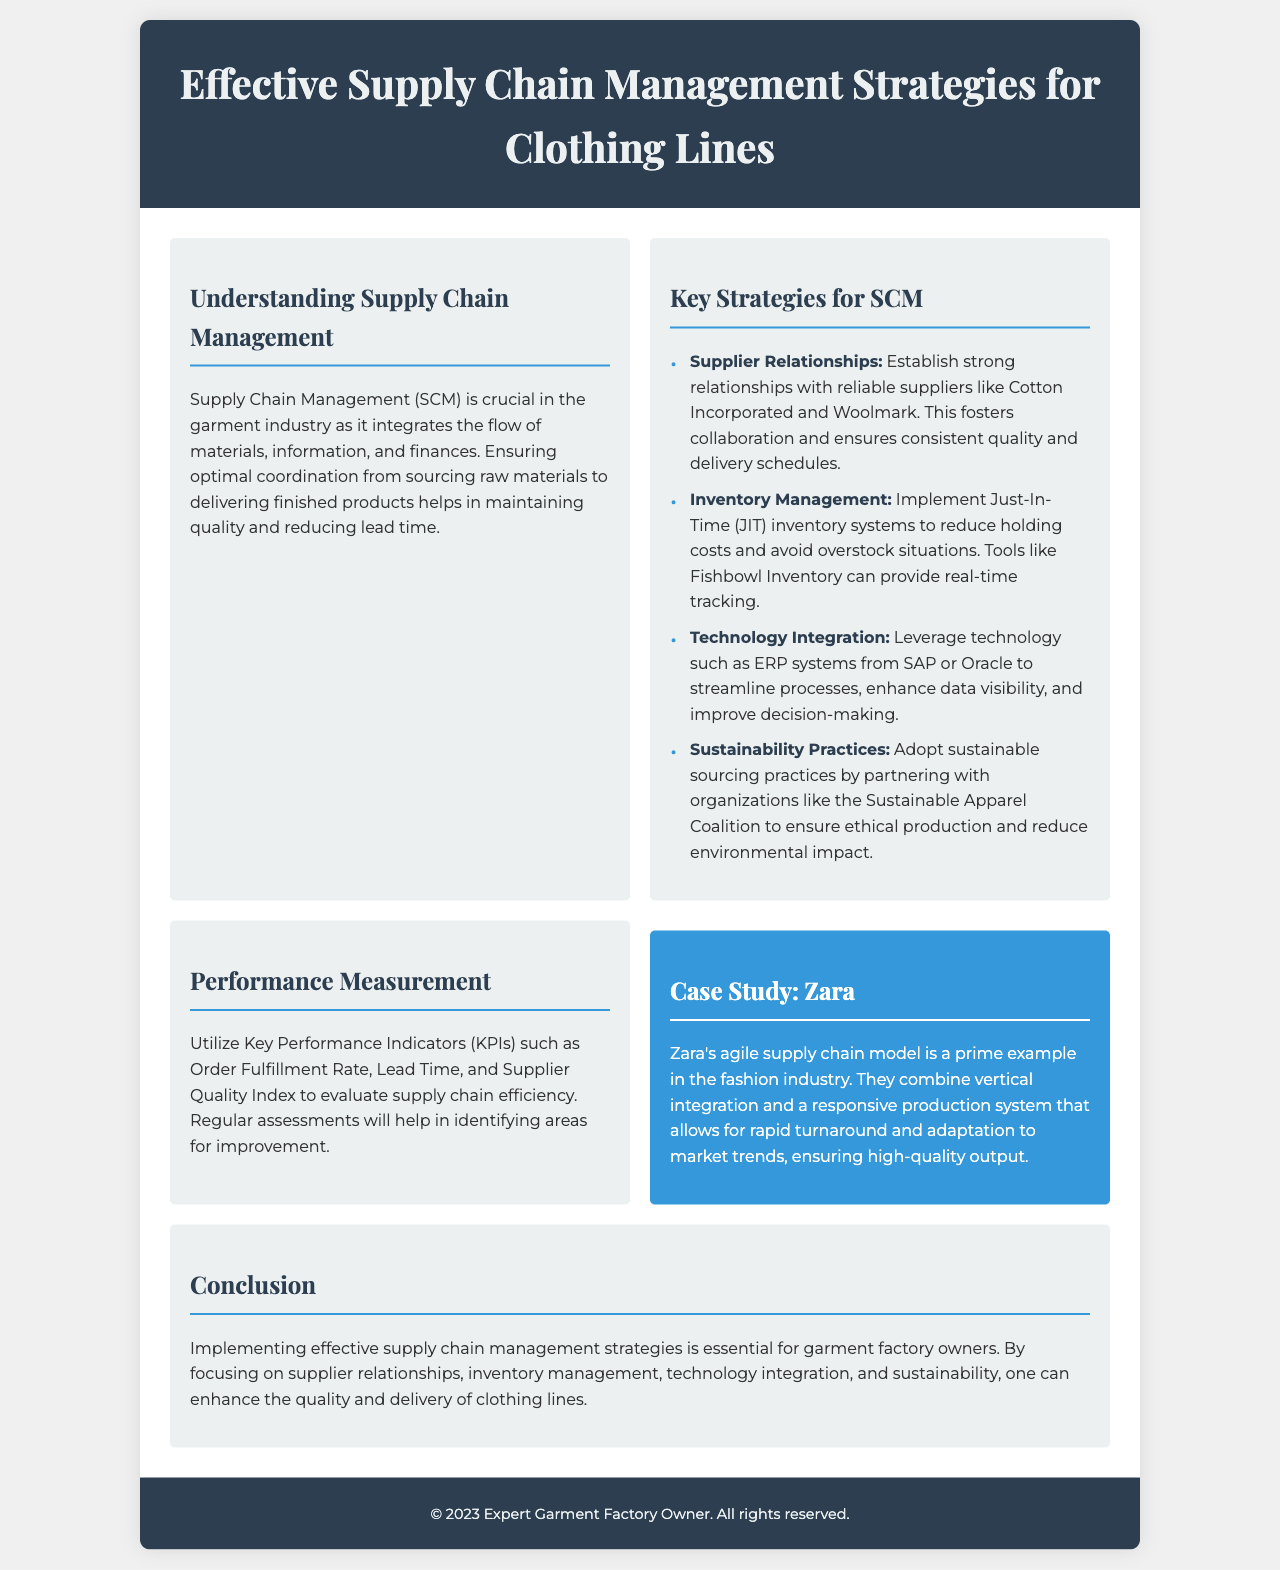What is the main focus of Supply Chain Management? The document states that Supply Chain Management integrates the flow of materials, information, and finances, and aims to maintain quality and reduce lead time.
Answer: Integrates the flow of materials, information, and finances Who is a reliable supplier mentioned in the strategies? The document lists Cotton Incorporated and Woolmark as examples of reliable suppliers for establishing strong relationships.
Answer: Cotton Incorporated What inventory system is recommended in the document? The brochure recommends implementing Just-In-Time (JIT) inventory systems to reduce holding costs.
Answer: Just-In-Time (JIT) Which technology is suggested for streamlining processes? The document mentions ERP systems from SAP or Oracle as technologies to streamline processes and improve decision-making.
Answer: ERP systems from SAP or Oracle What KPI is suggested for evaluating supply chain efficiency? The document lists Order Fulfillment Rate as one of the Key Performance Indicators to evaluate supply chain efficiency.
Answer: Order Fulfillment Rate What is a notable case study mentioned in the brochure? Zara's agile supply chain model is highlighted as a notable case study demonstrating effective supply chain strategies in the fashion industry.
Answer: Zara How does Zara ensure high-quality output? The document explains that Zara combines vertical integration and a responsive production system, allowing them to adapt rapidly to market trends.
Answer: Vertical integration and responsive production system What is a key sustainable practice recommended? The brochure suggests adopting sustainable sourcing practices by partnering with organizations like the Sustainable Apparel Coalition.
Answer: Sustainable sourcing practices What is the primary benefit of effective supply chain management? The summary concludes that focusing on key management strategies enhances the quality and delivery of clothing lines.
Answer: Enhances quality and delivery 